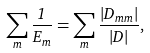<formula> <loc_0><loc_0><loc_500><loc_500>\sum _ { m } \frac { 1 } { E _ { m } } = \sum _ { m } \frac { \left | D _ { m m } \right | } { | D | } ,</formula> 